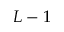<formula> <loc_0><loc_0><loc_500><loc_500>L - 1</formula> 